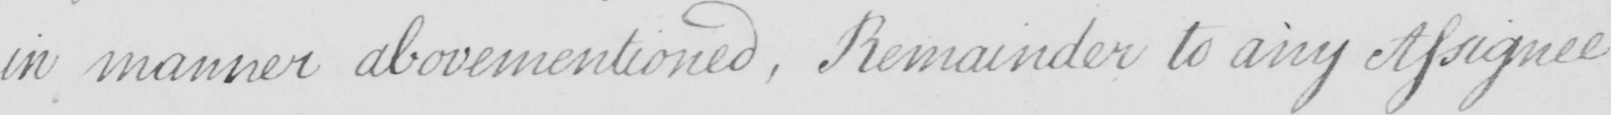Please transcribe the handwritten text in this image. in manner abovementioned , Remainder to any Assignee 